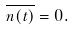Convert formula to latex. <formula><loc_0><loc_0><loc_500><loc_500>\overline { n ( t ) } = 0 .</formula> 